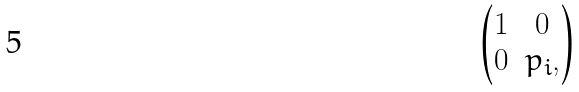Convert formula to latex. <formula><loc_0><loc_0><loc_500><loc_500>\begin{pmatrix} 1 & 0 \\ 0 & p _ { i } , \end{pmatrix}</formula> 